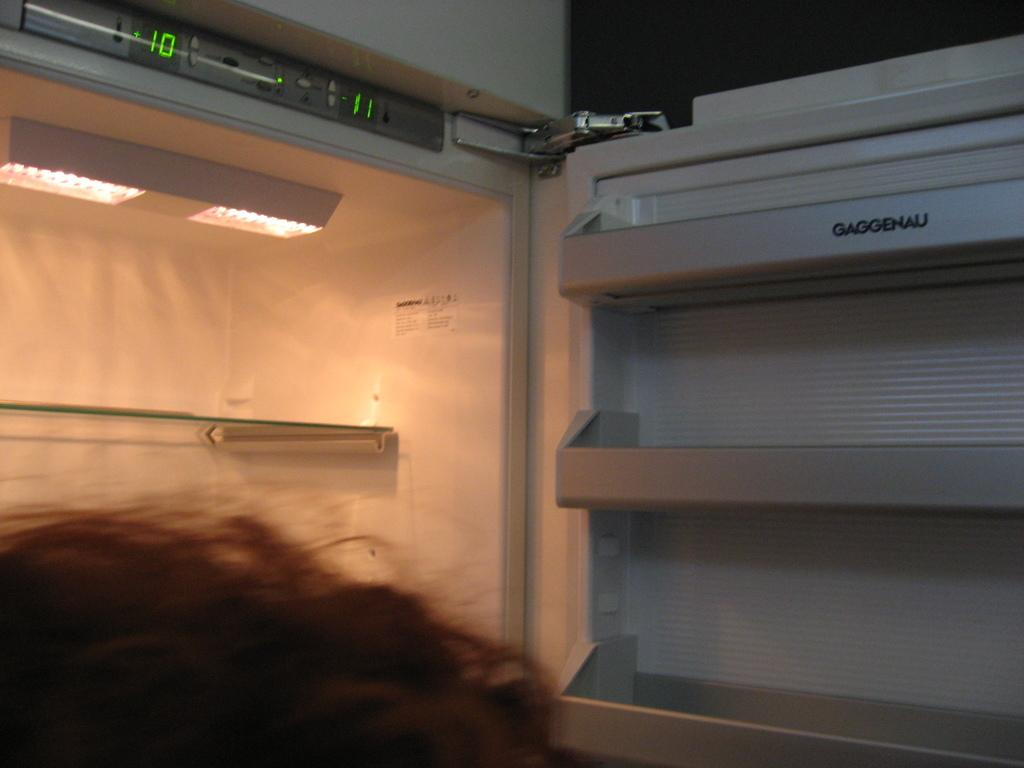What is present in the image? There is a person in the image. Can you describe the person's appearance? The person's hair is visible in the image. What object is present in the image that is typically used for storing food? There is an opened fridge in the image. What type of songs can be heard playing in the background of the image? There is no indication of any songs playing in the image, as it only features a person and an opened fridge. 